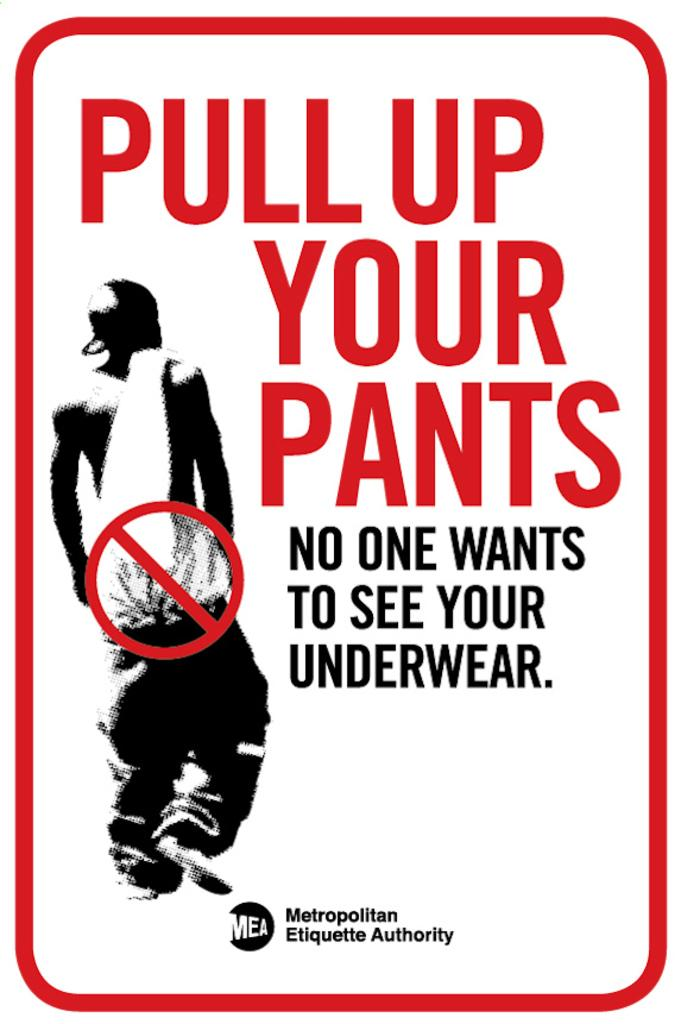<image>
Give a short and clear explanation of the subsequent image. a sign asking people to pull up your pants 